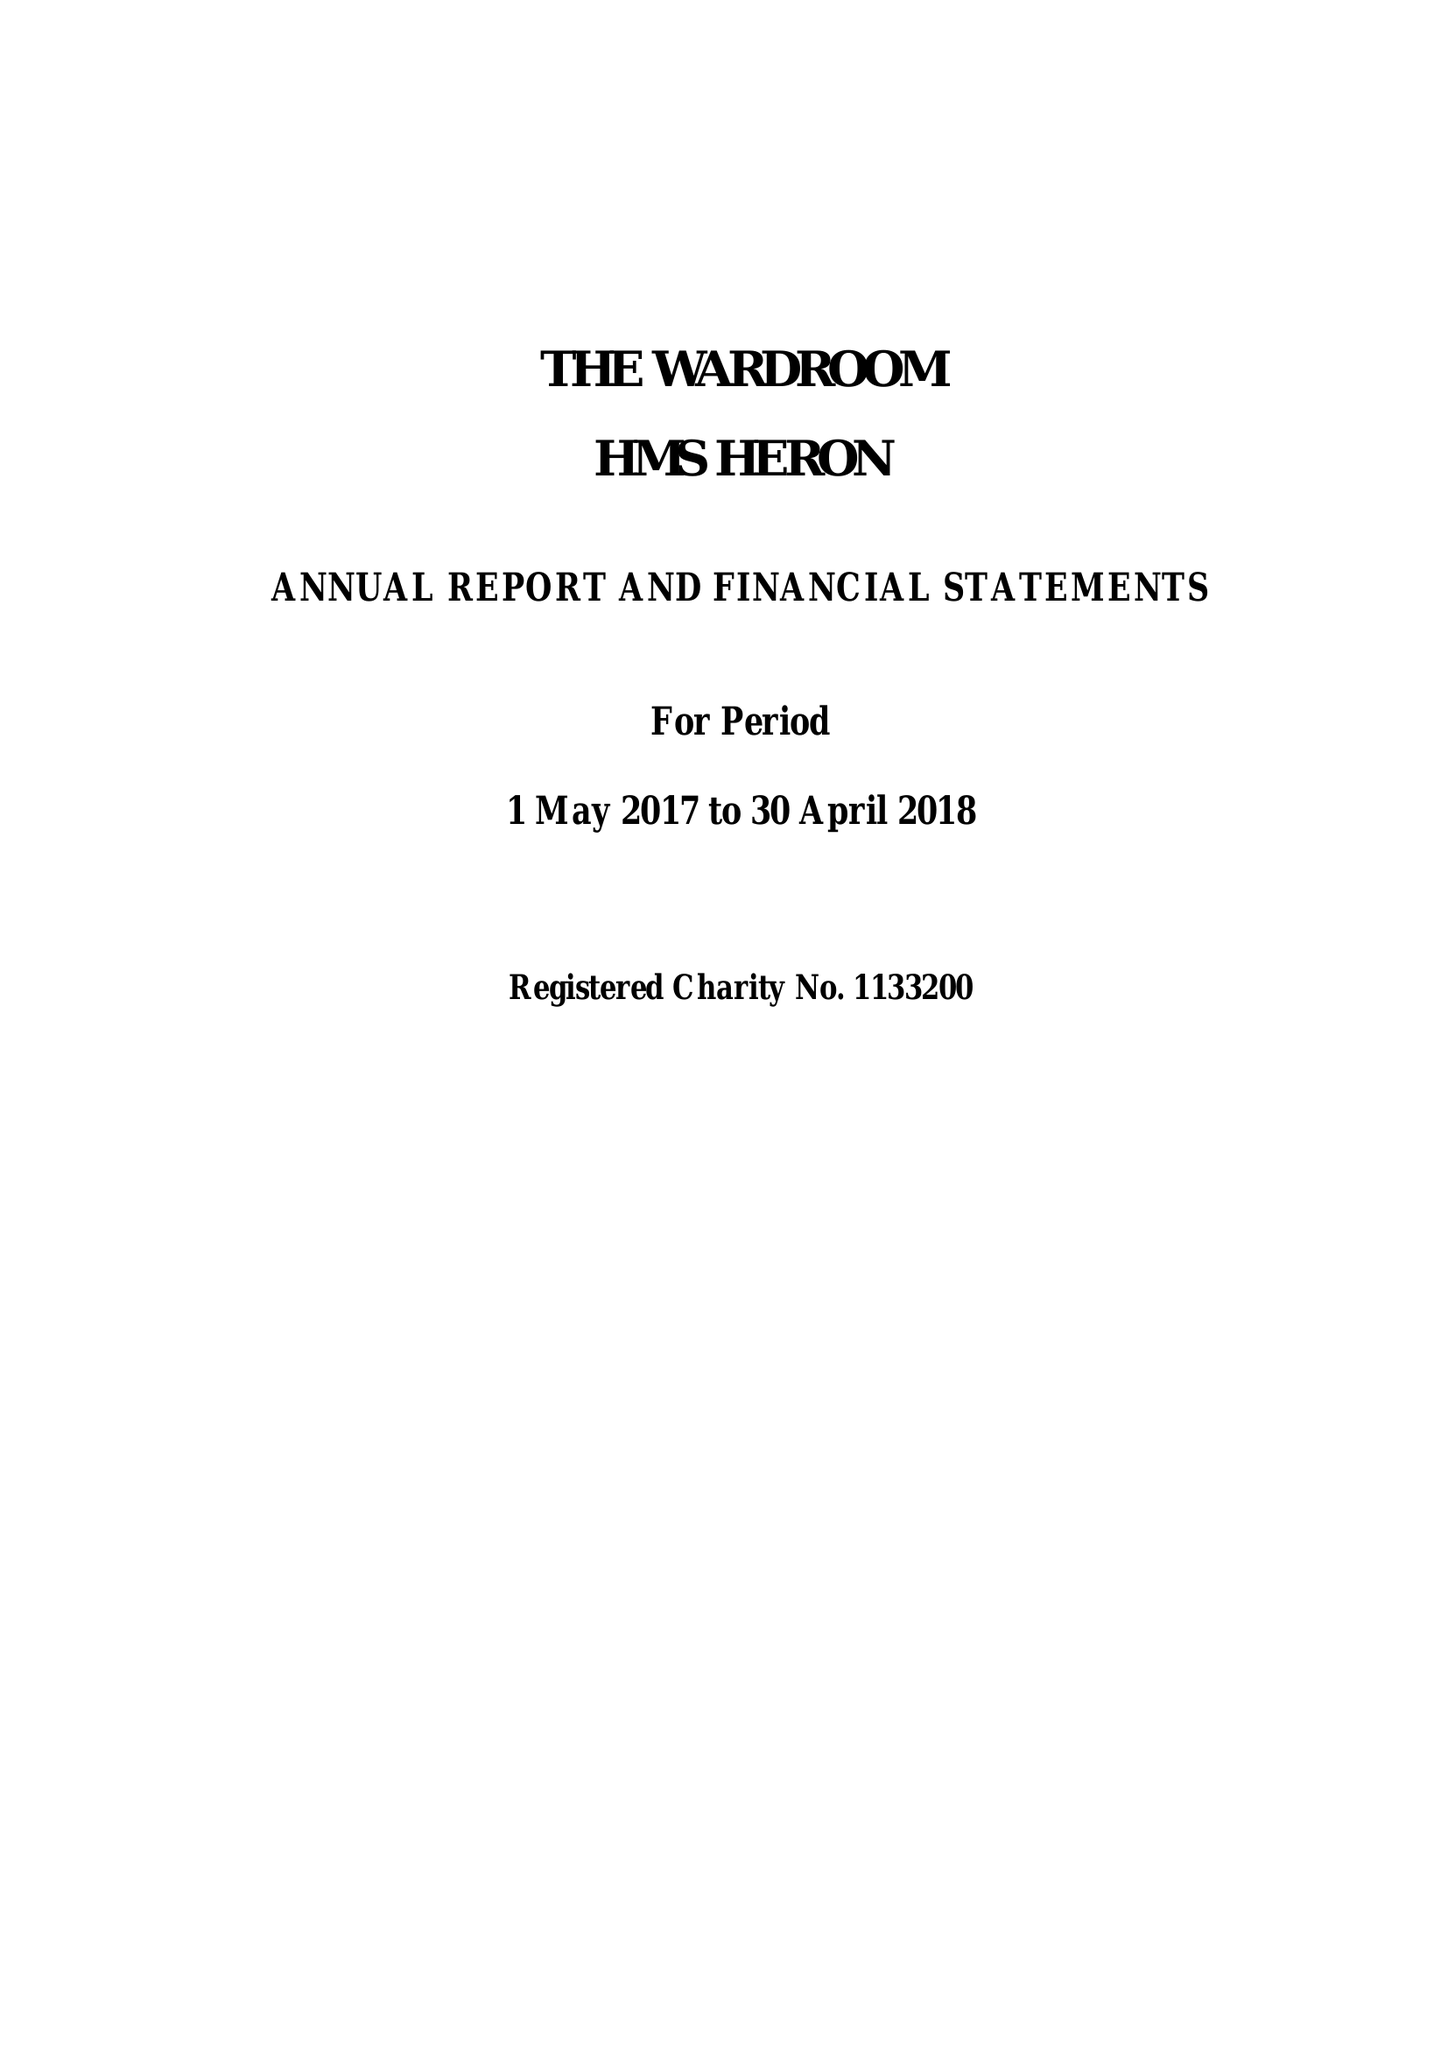What is the value for the report_date?
Answer the question using a single word or phrase. 2018-04-30 